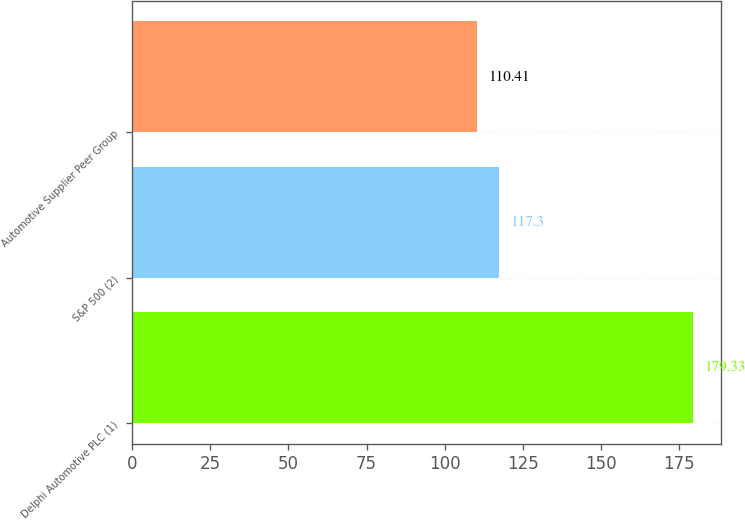Convert chart. <chart><loc_0><loc_0><loc_500><loc_500><bar_chart><fcel>Delphi Automotive PLC (1)<fcel>S&P 500 (2)<fcel>Automotive Supplier Peer Group<nl><fcel>179.33<fcel>117.3<fcel>110.41<nl></chart> 